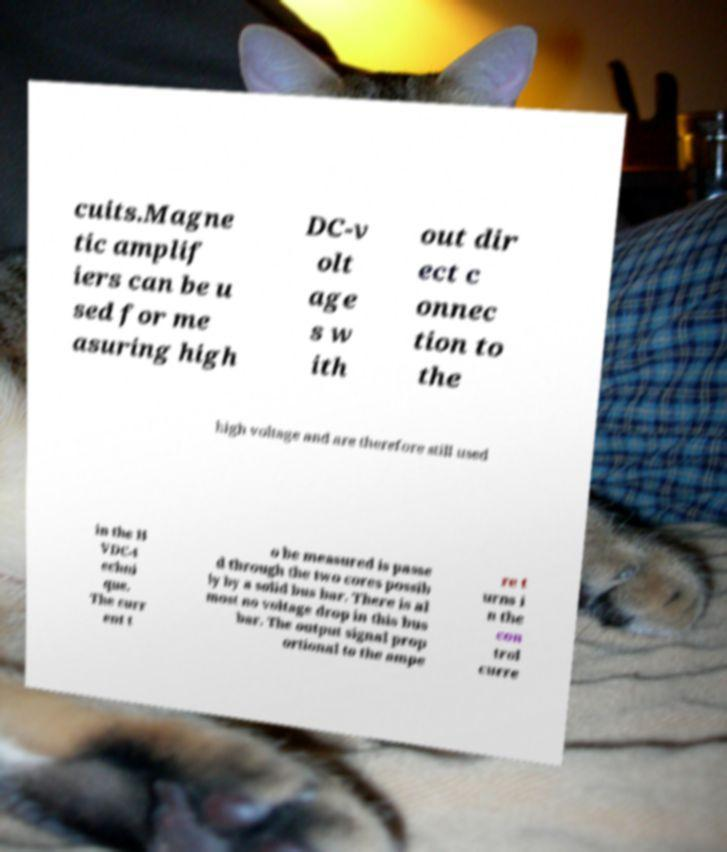Can you read and provide the text displayed in the image?This photo seems to have some interesting text. Can you extract and type it out for me? cuits.Magne tic amplif iers can be u sed for me asuring high DC-v olt age s w ith out dir ect c onnec tion to the high voltage and are therefore still used in the H VDC-t echni que. The curr ent t o be measured is passe d through the two cores possib ly by a solid bus bar. There is al most no voltage drop in this bus bar. The output signal prop ortional to the ampe re t urns i n the con trol curre 